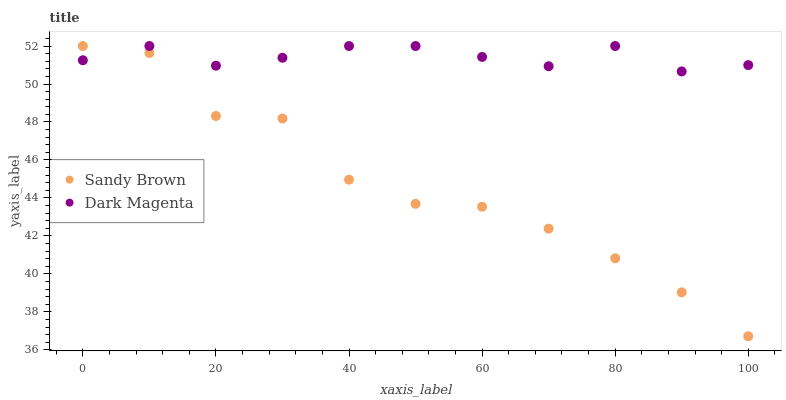Does Sandy Brown have the minimum area under the curve?
Answer yes or no. Yes. Does Dark Magenta have the maximum area under the curve?
Answer yes or no. Yes. Does Dark Magenta have the minimum area under the curve?
Answer yes or no. No. Is Dark Magenta the smoothest?
Answer yes or no. Yes. Is Sandy Brown the roughest?
Answer yes or no. Yes. Is Dark Magenta the roughest?
Answer yes or no. No. Does Sandy Brown have the lowest value?
Answer yes or no. Yes. Does Dark Magenta have the lowest value?
Answer yes or no. No. Does Dark Magenta have the highest value?
Answer yes or no. Yes. Does Dark Magenta intersect Sandy Brown?
Answer yes or no. Yes. Is Dark Magenta less than Sandy Brown?
Answer yes or no. No. Is Dark Magenta greater than Sandy Brown?
Answer yes or no. No. 